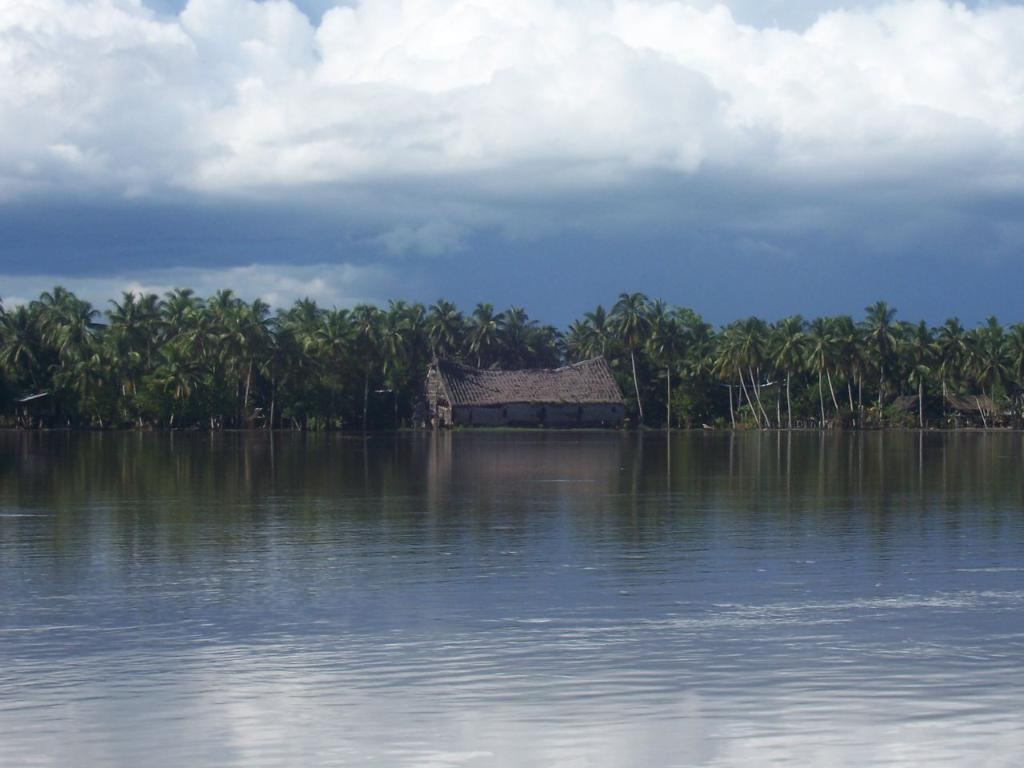What is the primary element visible in the image? There is water in the image. What structures can be seen in the background of the image? There is a shed and trees in the background of the image. What part of the natural environment is visible in the image? The sky is visible in the background of the image. What can be observed in the sky? Clouds are present in the sky. Where is the frog hoping to find a new home in the image? There is no frog present in the image, so it cannot be determined where it might be hoping to find a new home. 